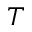<formula> <loc_0><loc_0><loc_500><loc_500>T</formula> 